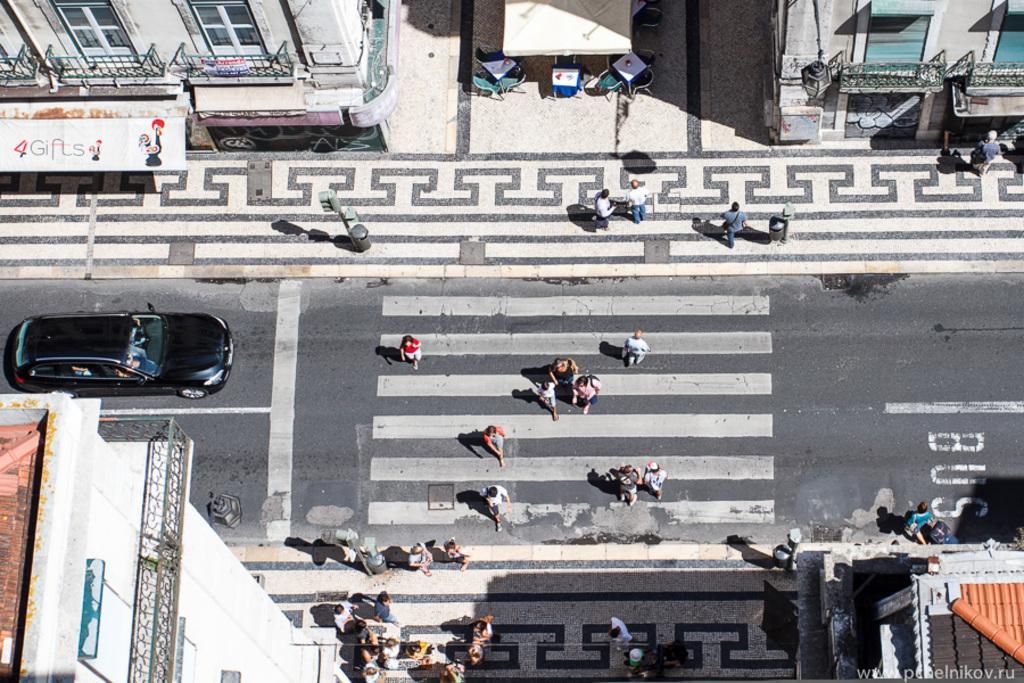How would you summarize this image in a sentence or two? In the picture we can see an Ariel view of the road with zebra lines and few people are walking on it and on the both the sides of the road we can see the path with designs and a part of the buildings near it. 